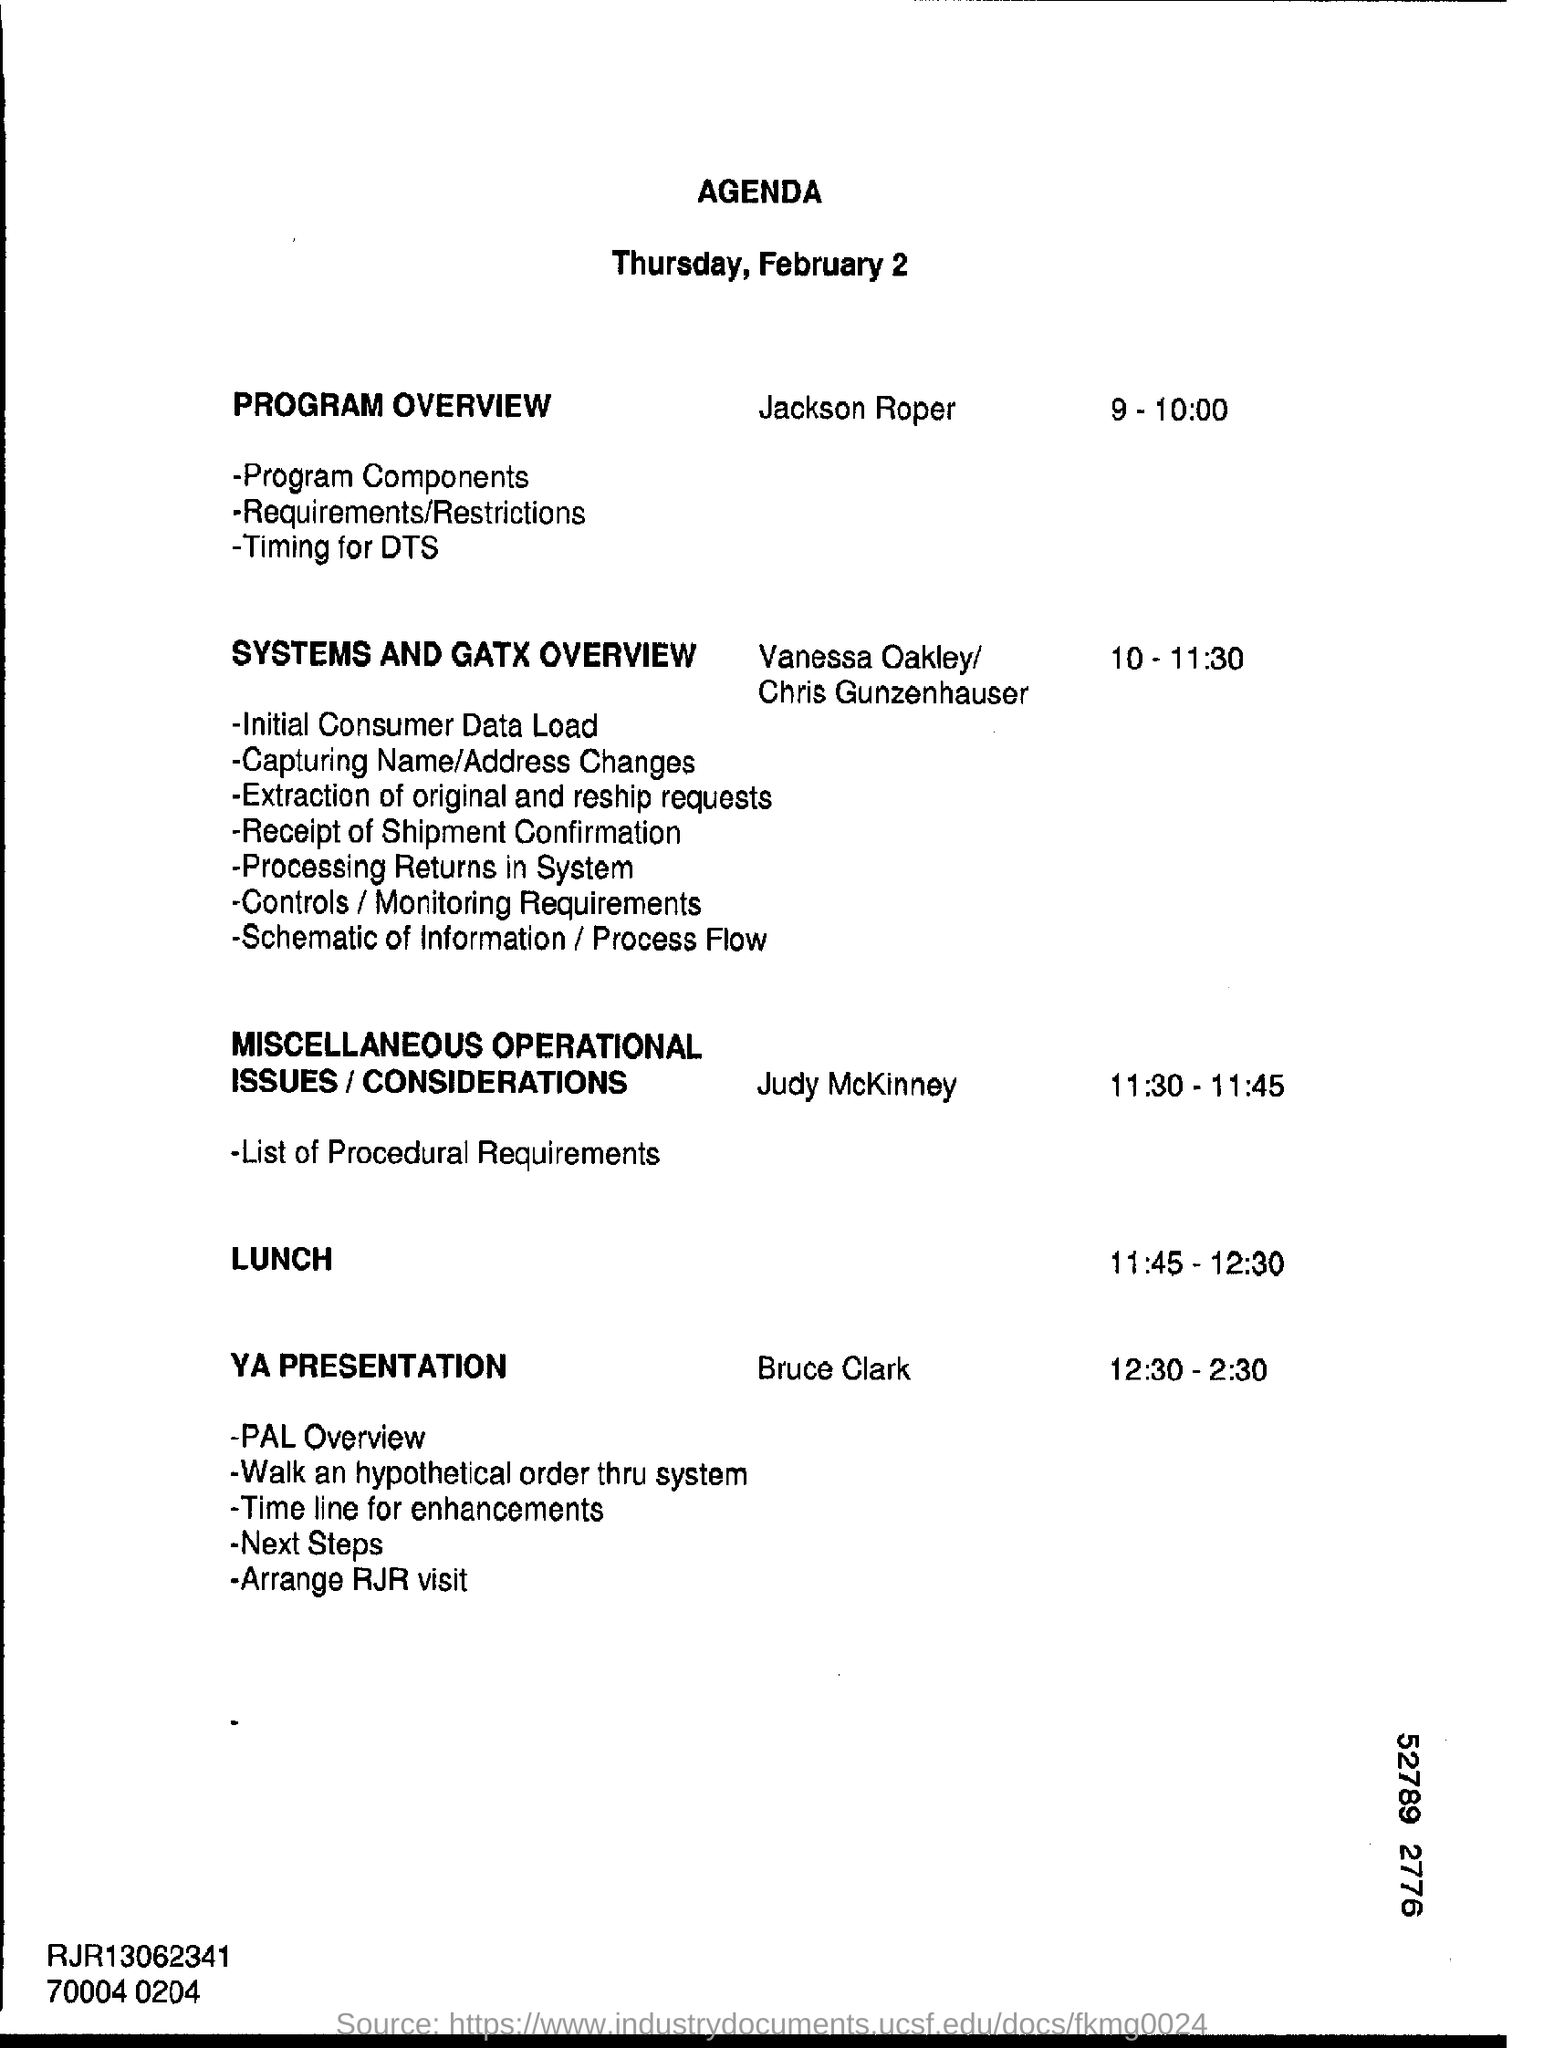What is the date mentioned in the top of the document ?
Offer a very short reply. Thursday,February2. What is the Lunch Time ?
Give a very brief answer. 11.45 - 12.30. What is the Time of  YA PRESENTATION ?
Keep it short and to the point. 12.30 - 2.30. 